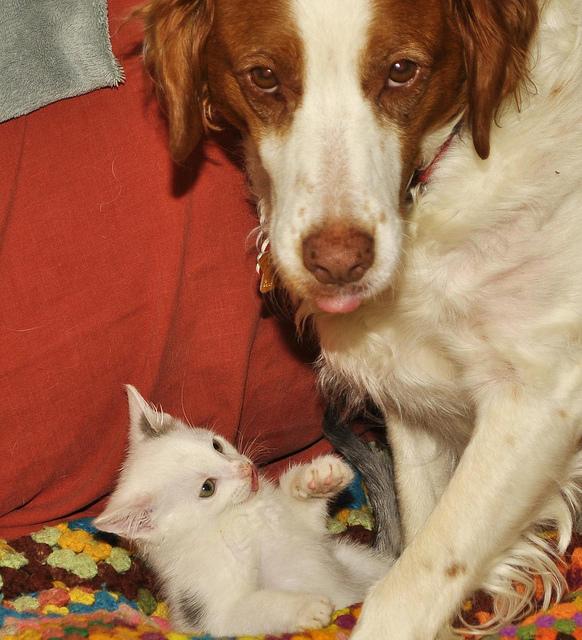How many animals are in this picture?
Quick response, please. 2. Are there more than one species of animal in this picture?
Concise answer only. Yes. Are the animals alive?
Keep it brief. Yes. 